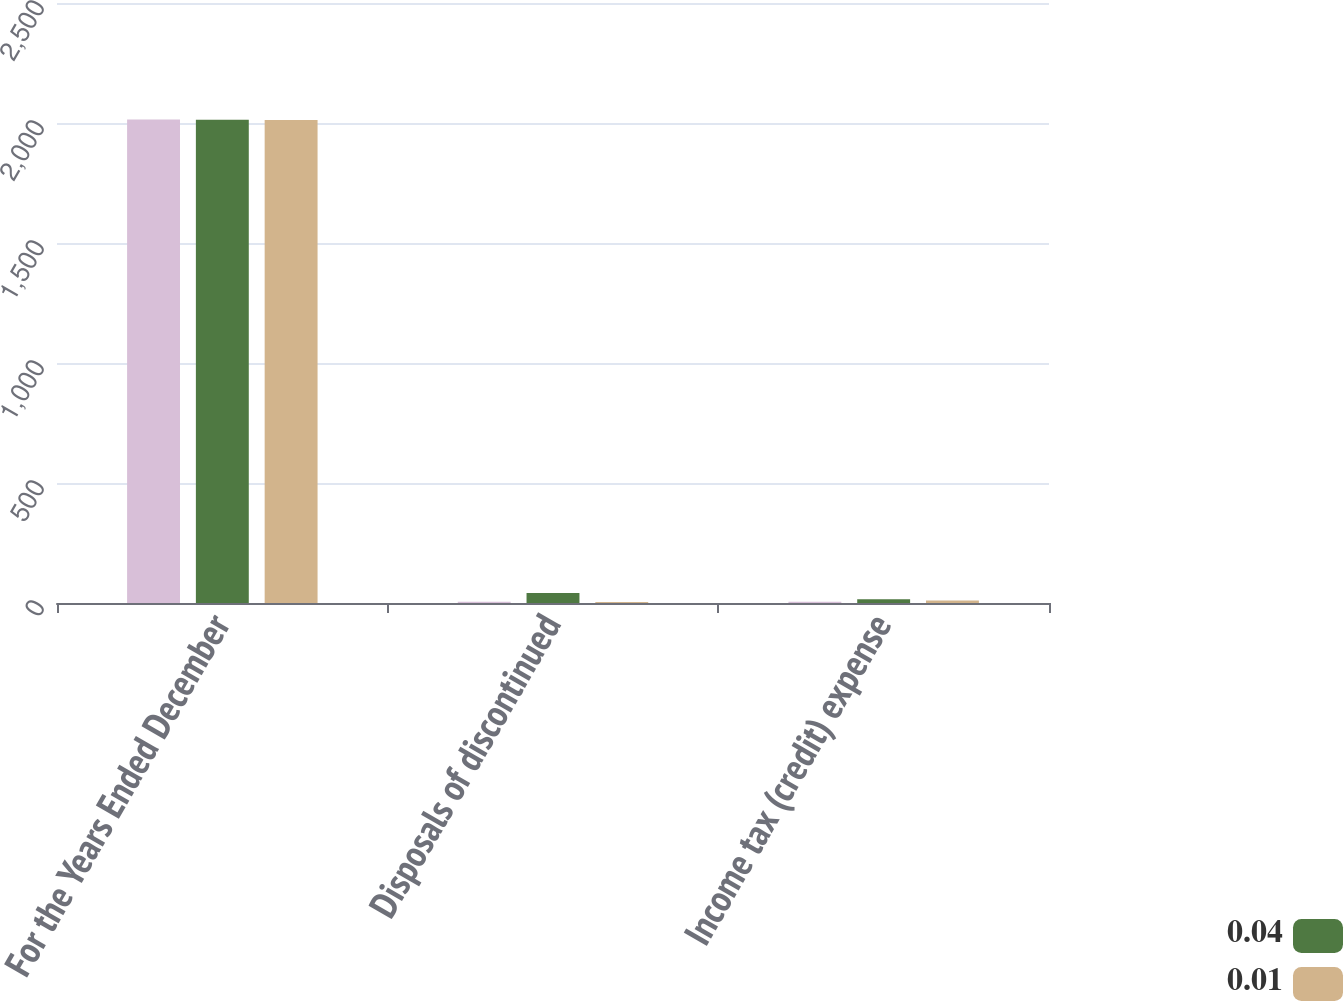Convert chart to OTSL. <chart><loc_0><loc_0><loc_500><loc_500><stacked_bar_chart><ecel><fcel>For the Years Ended December<fcel>Disposals of discontinued<fcel>Income tax (credit) expense<nl><fcel>nan<fcel>2015<fcel>5<fcel>5<nl><fcel>0.04<fcel>2014<fcel>42<fcel>16<nl><fcel>0.01<fcel>2013<fcel>4<fcel>10<nl></chart> 